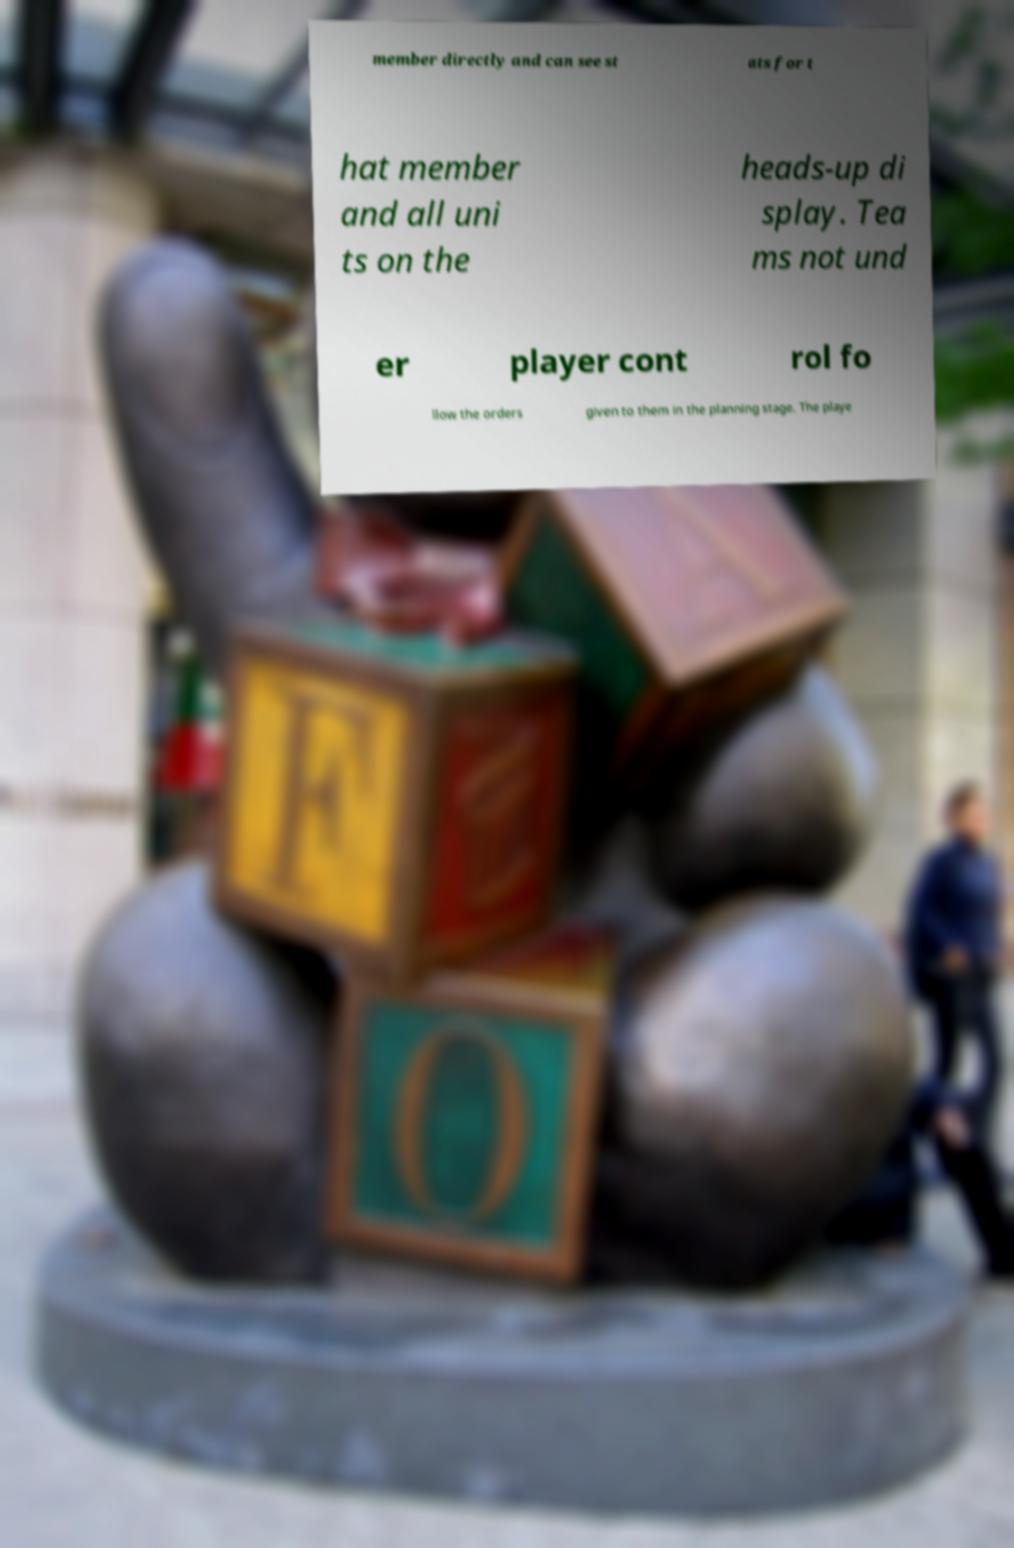Please read and relay the text visible in this image. What does it say? member directly and can see st ats for t hat member and all uni ts on the heads-up di splay. Tea ms not und er player cont rol fo llow the orders given to them in the planning stage. The playe 